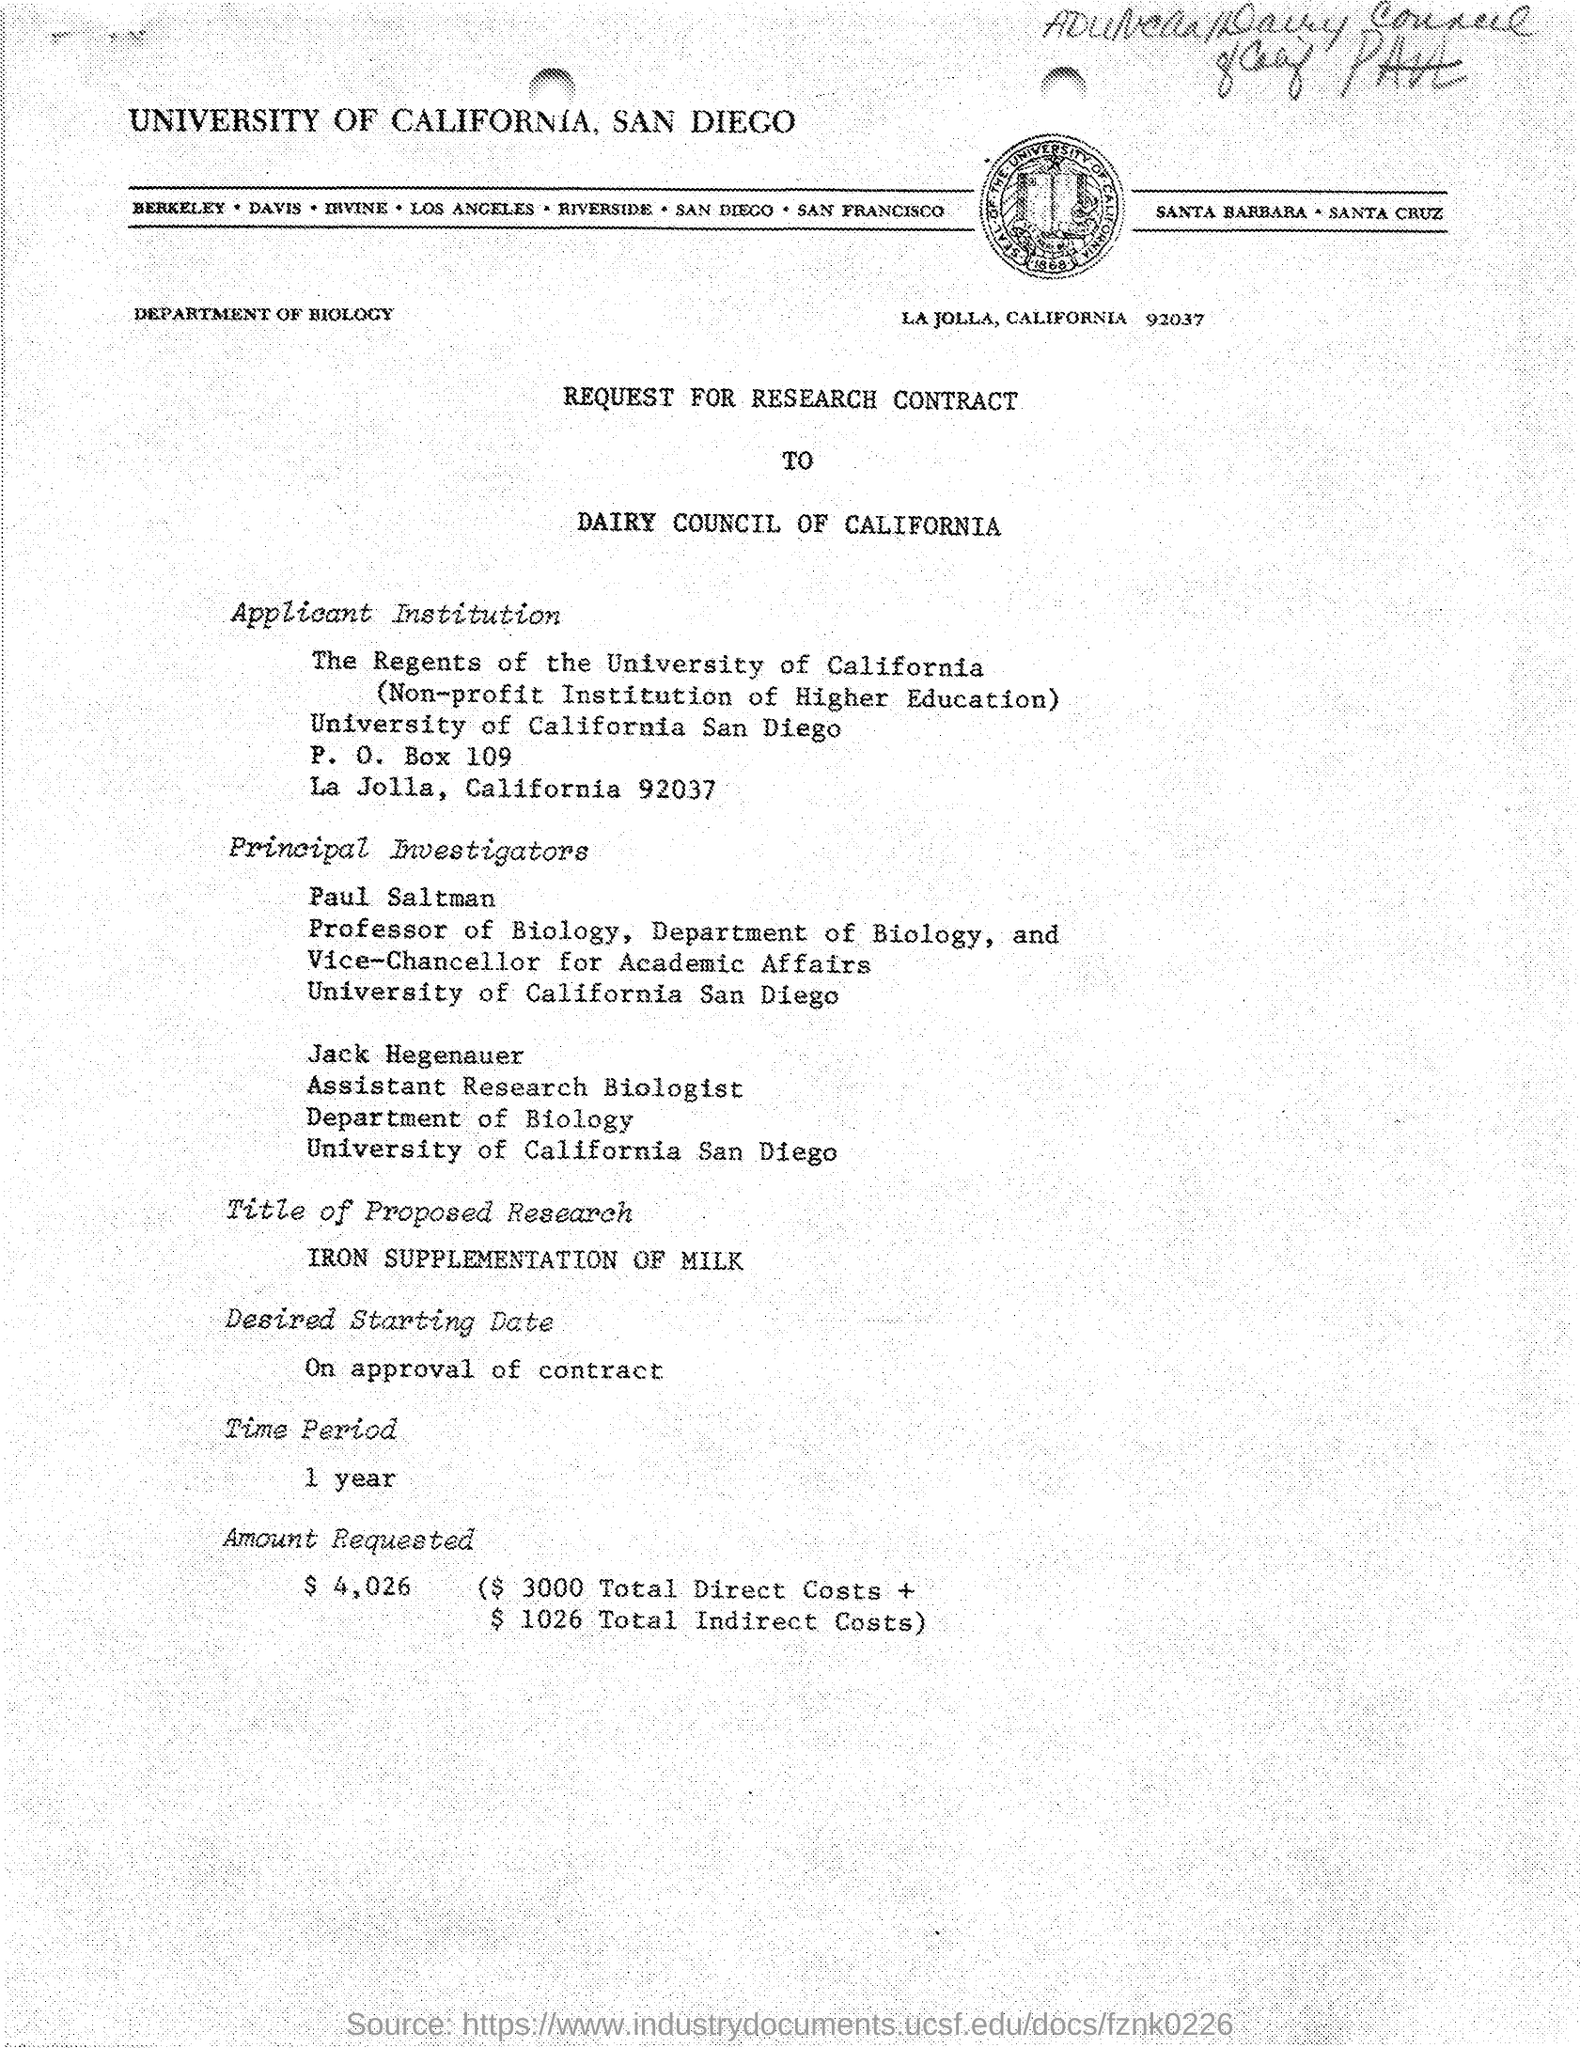Highlight a few significant elements in this photo. The amount requested is $4,026. The time period is one year. The total direct costs are $3000. The department is the Department of Biology. The desired starting date for the project will be on approval of the contract. 